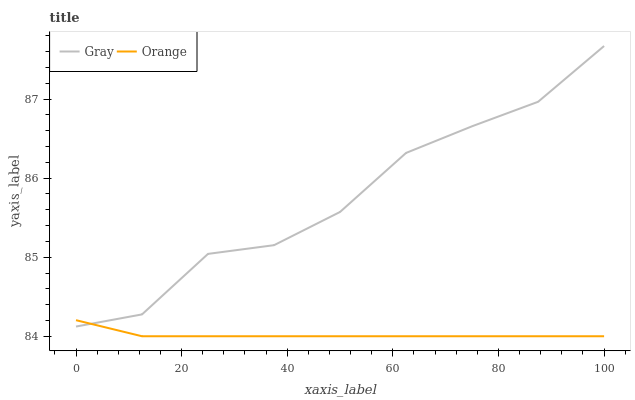Does Orange have the minimum area under the curve?
Answer yes or no. Yes. Does Gray have the maximum area under the curve?
Answer yes or no. Yes. Does Gray have the minimum area under the curve?
Answer yes or no. No. Is Orange the smoothest?
Answer yes or no. Yes. Is Gray the roughest?
Answer yes or no. Yes. Is Gray the smoothest?
Answer yes or no. No. Does Orange have the lowest value?
Answer yes or no. Yes. Does Gray have the lowest value?
Answer yes or no. No. Does Gray have the highest value?
Answer yes or no. Yes. Does Orange intersect Gray?
Answer yes or no. Yes. Is Orange less than Gray?
Answer yes or no. No. Is Orange greater than Gray?
Answer yes or no. No. 